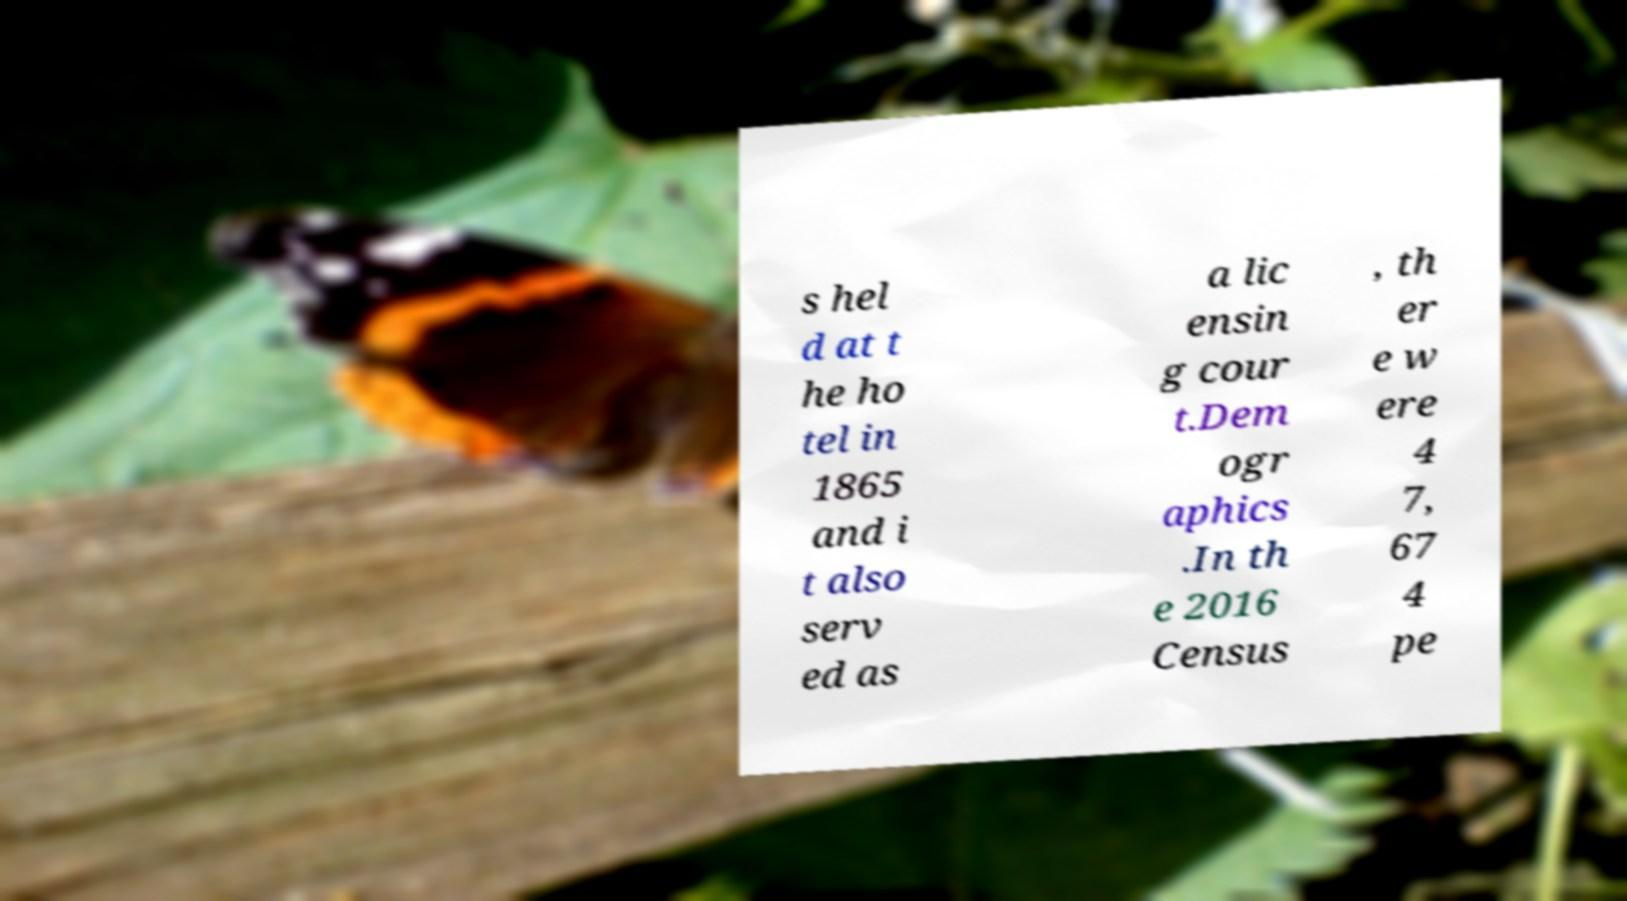Please identify and transcribe the text found in this image. s hel d at t he ho tel in 1865 and i t also serv ed as a lic ensin g cour t.Dem ogr aphics .In th e 2016 Census , th er e w ere 4 7, 67 4 pe 